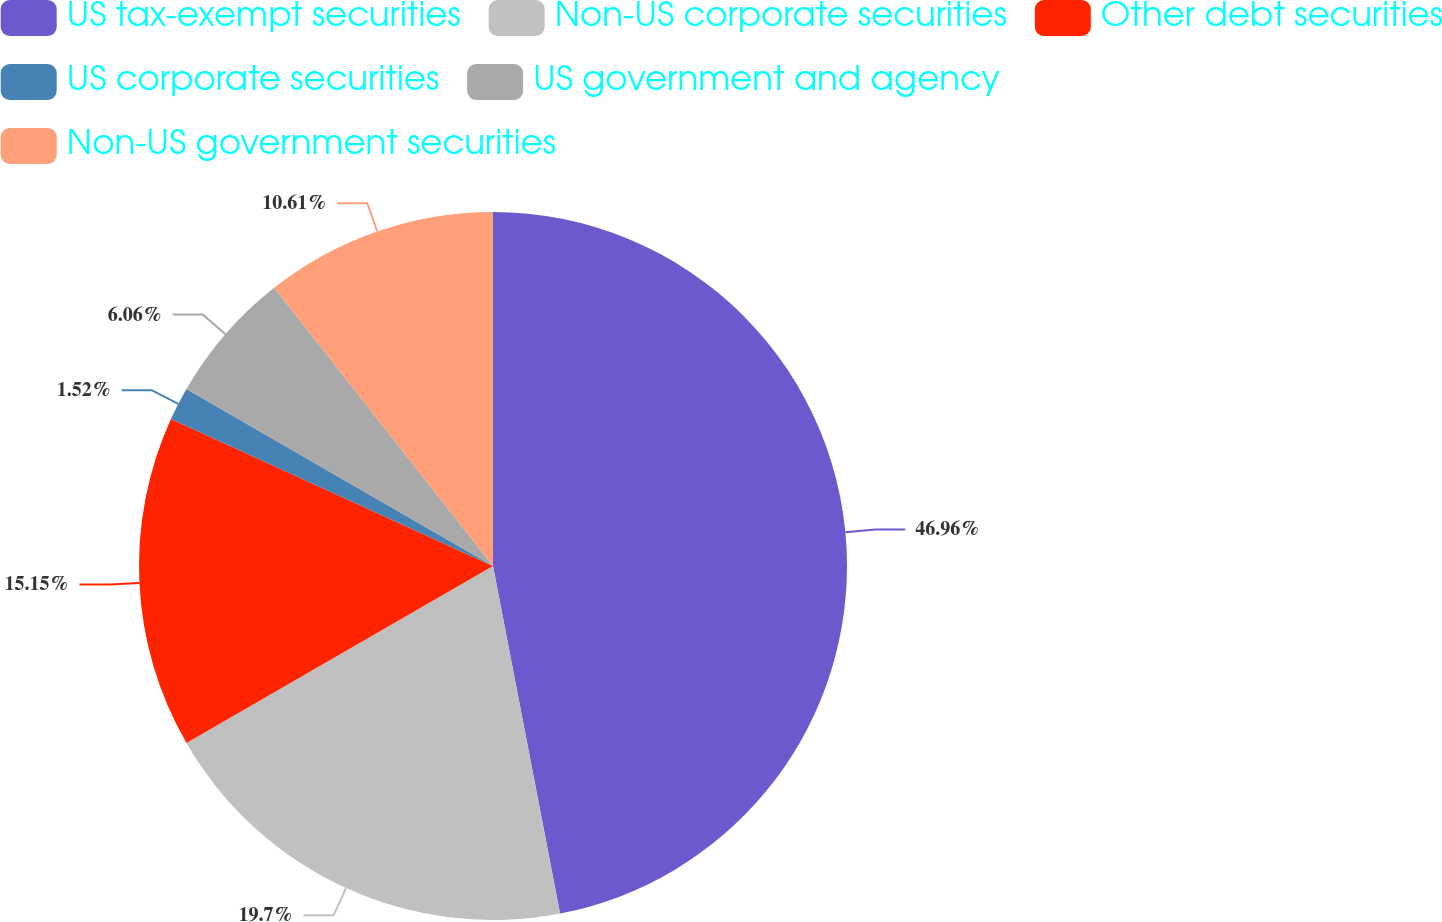Convert chart to OTSL. <chart><loc_0><loc_0><loc_500><loc_500><pie_chart><fcel>US tax-exempt securities<fcel>Non-US corporate securities<fcel>Other debt securities<fcel>US corporate securities<fcel>US government and agency<fcel>Non-US government securities<nl><fcel>46.97%<fcel>19.7%<fcel>15.15%<fcel>1.52%<fcel>6.06%<fcel>10.61%<nl></chart> 